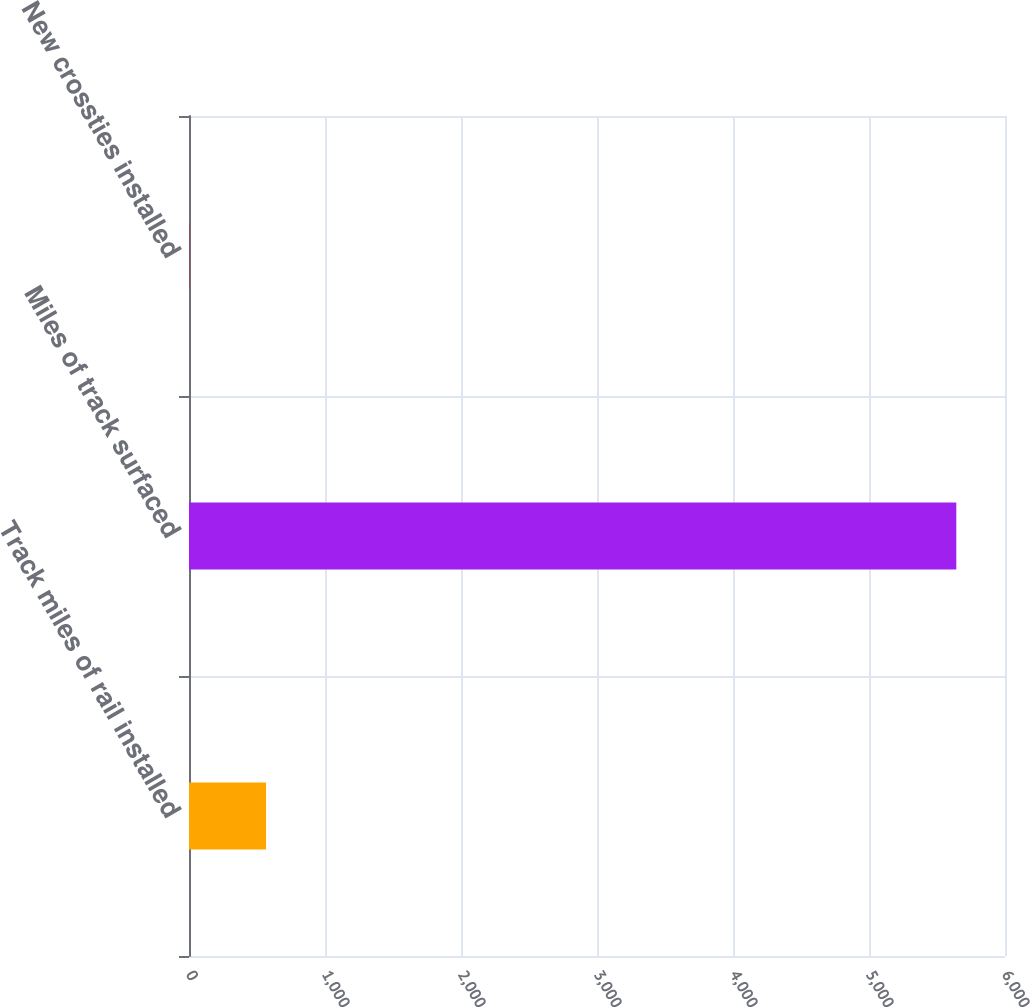<chart> <loc_0><loc_0><loc_500><loc_500><bar_chart><fcel>Track miles of rail installed<fcel>Miles of track surfaced<fcel>New crossties installed<nl><fcel>566.54<fcel>5642<fcel>2.6<nl></chart> 